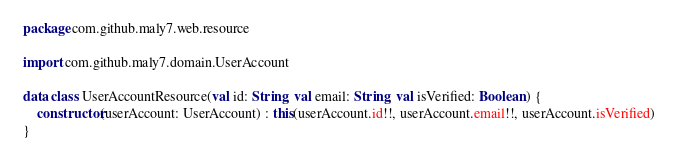Convert code to text. <code><loc_0><loc_0><loc_500><loc_500><_Kotlin_>package com.github.maly7.web.resource

import com.github.maly7.domain.UserAccount

data class UserAccountResource(val id: String, val email: String, val isVerified: Boolean) {
    constructor(userAccount: UserAccount) : this(userAccount.id!!, userAccount.email!!, userAccount.isVerified)
}
</code> 